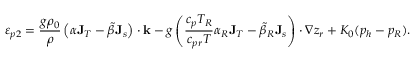<formula> <loc_0><loc_0><loc_500><loc_500>\varepsilon _ { p 2 } = \frac { g \rho _ { 0 } } { \rho } \left ( \alpha { J } _ { T } - \tilde { \beta } { J } _ { s } \right ) \cdot { k } - g \left ( \frac { c _ { p } T _ { R } } { c _ { p r } T } \alpha _ { R } { J } _ { T } - \tilde { \beta } _ { R } { J } _ { s } \right ) \cdot \nabla z _ { r } + K _ { 0 } ( p _ { h } - p _ { R } ) .</formula> 